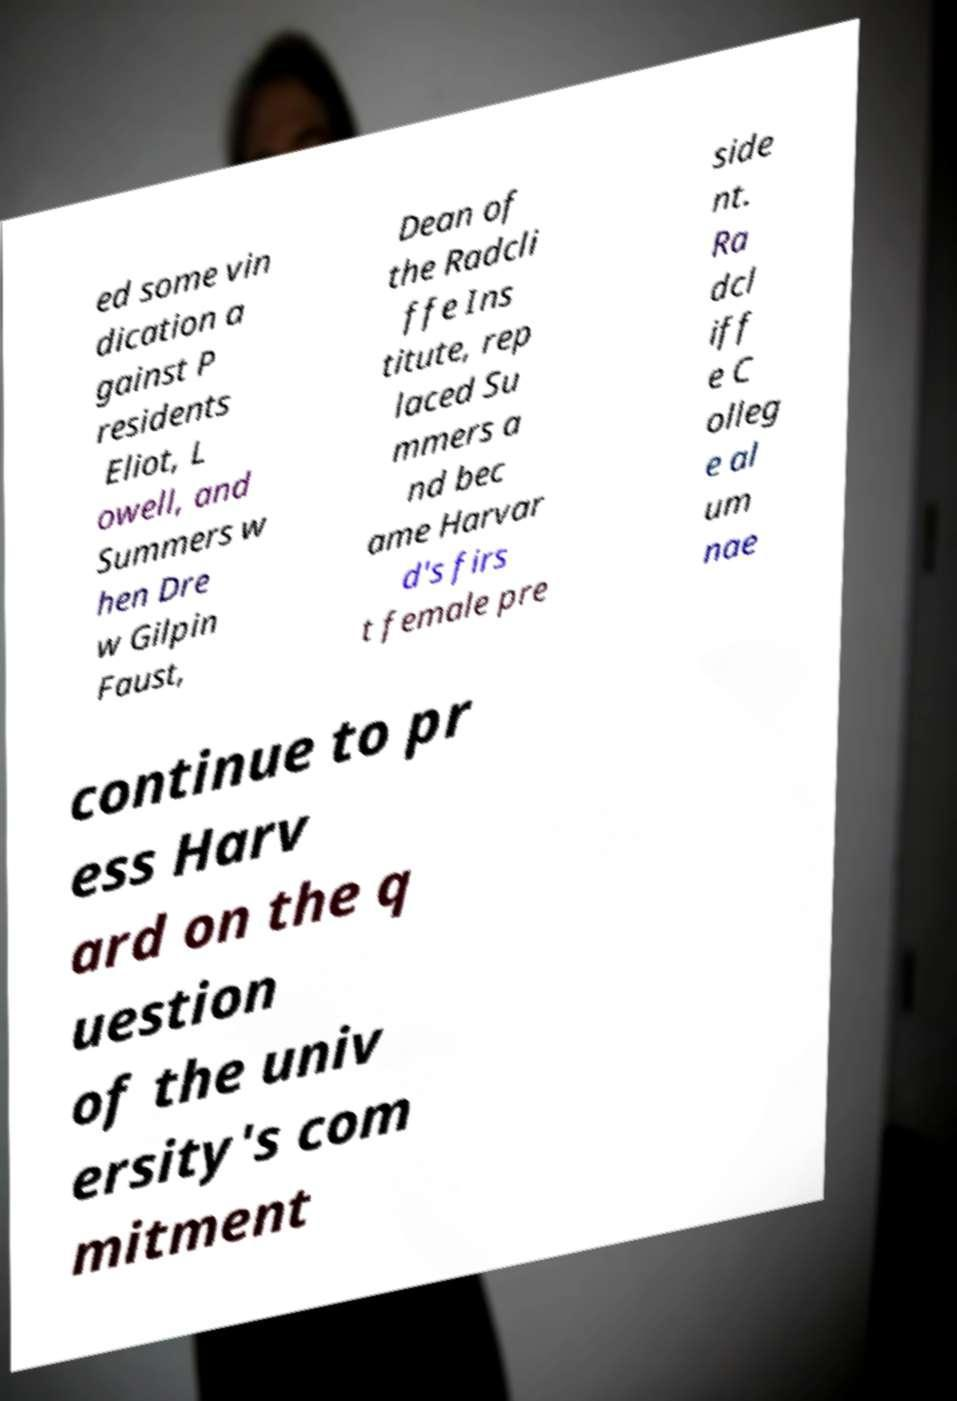Could you assist in decoding the text presented in this image and type it out clearly? ed some vin dication a gainst P residents Eliot, L owell, and Summers w hen Dre w Gilpin Faust, Dean of the Radcli ffe Ins titute, rep laced Su mmers a nd bec ame Harvar d's firs t female pre side nt. Ra dcl iff e C olleg e al um nae continue to pr ess Harv ard on the q uestion of the univ ersity's com mitment 